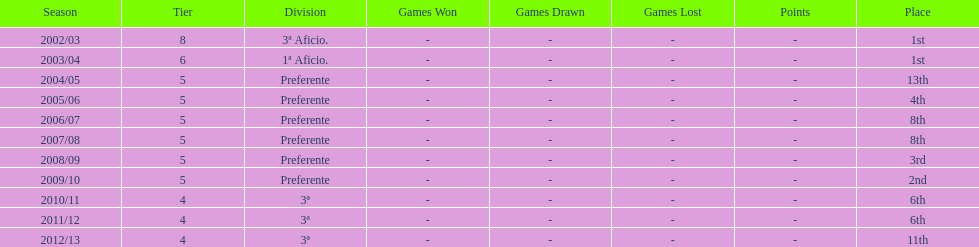In what year was the team's ranking identical to their 2010/11 standing? 2011/12. I'm looking to parse the entire table for insights. Could you assist me with that? {'header': ['Season', 'Tier', 'Division', 'Games Won', 'Games Drawn', 'Games Lost', 'Points', 'Place'], 'rows': [['2002/03', '8', '3ª Aficio.', '-', '-', '-', '-', '1st'], ['2003/04', '6', '1ª Aficio.', '-', '-', '-', '-', '1st'], ['2004/05', '5', 'Preferente', '-', '-', '-', '-', '13th'], ['2005/06', '5', 'Preferente', '-', '-', '-', '-', '4th'], ['2006/07', '5', 'Preferente', '-', '-', '-', '-', '8th'], ['2007/08', '5', 'Preferente', '-', '-', '-', '-', '8th'], ['2008/09', '5', 'Preferente', '-', '-', '-', '-', '3rd'], ['2009/10', '5', 'Preferente', '-', '-', '-', '-', '2nd'], ['2010/11', '4', '3ª', '-', '-', '-', '-', '6th'], ['2011/12', '4', '3ª', '-', '-', '-', '-', '6th'], ['2012/13', '4', '3ª', '-', '-', '-', '-', '11th']]} 